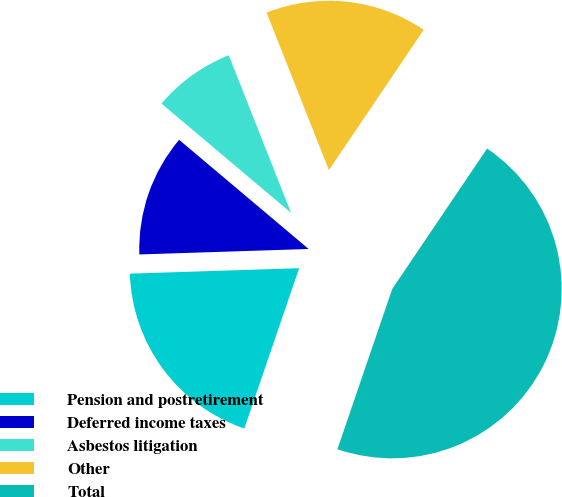<chart> <loc_0><loc_0><loc_500><loc_500><pie_chart><fcel>Pension and postretirement<fcel>Deferred income taxes<fcel>Asbestos litigation<fcel>Other<fcel>Total<nl><fcel>19.24%<fcel>11.66%<fcel>7.86%<fcel>15.45%<fcel>45.79%<nl></chart> 